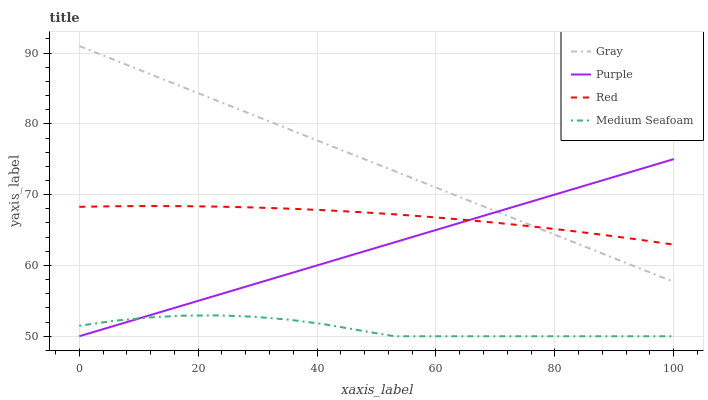Does Medium Seafoam have the minimum area under the curve?
Answer yes or no. Yes. Does Gray have the maximum area under the curve?
Answer yes or no. Yes. Does Gray have the minimum area under the curve?
Answer yes or no. No. Does Medium Seafoam have the maximum area under the curve?
Answer yes or no. No. Is Purple the smoothest?
Answer yes or no. Yes. Is Medium Seafoam the roughest?
Answer yes or no. Yes. Is Gray the smoothest?
Answer yes or no. No. Is Gray the roughest?
Answer yes or no. No. Does Gray have the lowest value?
Answer yes or no. No. Does Gray have the highest value?
Answer yes or no. Yes. Does Medium Seafoam have the highest value?
Answer yes or no. No. Is Medium Seafoam less than Gray?
Answer yes or no. Yes. Is Red greater than Medium Seafoam?
Answer yes or no. Yes. Does Medium Seafoam intersect Purple?
Answer yes or no. Yes. Is Medium Seafoam less than Purple?
Answer yes or no. No. Is Medium Seafoam greater than Purple?
Answer yes or no. No. Does Medium Seafoam intersect Gray?
Answer yes or no. No. 